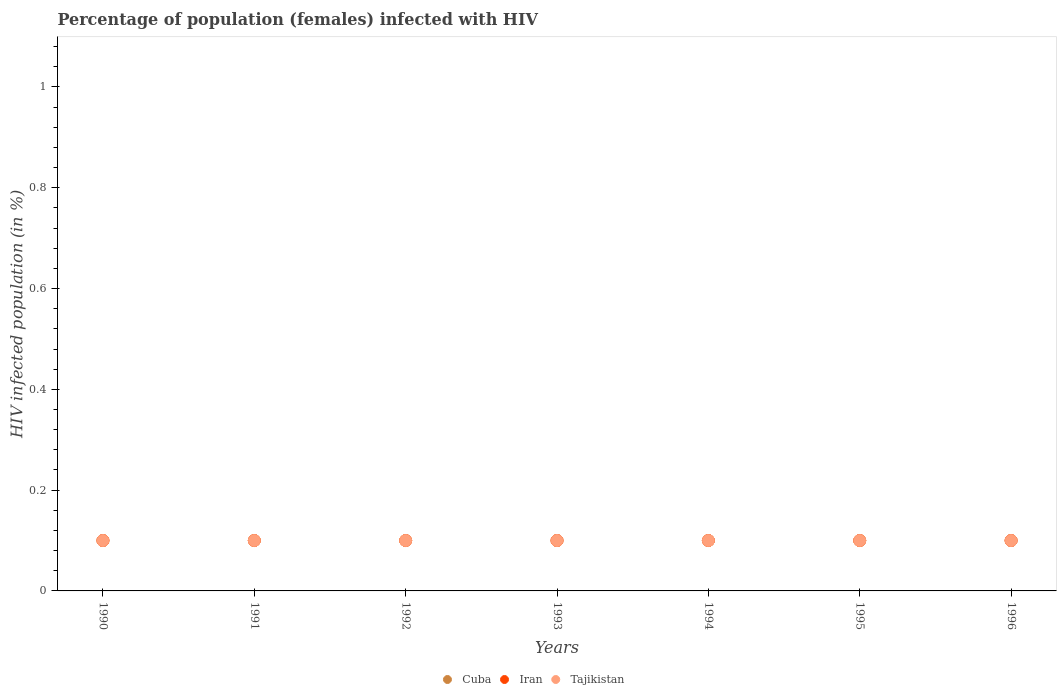How many different coloured dotlines are there?
Your response must be concise. 3. Is the number of dotlines equal to the number of legend labels?
Give a very brief answer. Yes. What is the percentage of HIV infected female population in Cuba in 1996?
Provide a succinct answer. 0.1. In which year was the percentage of HIV infected female population in Tajikistan maximum?
Provide a succinct answer. 1990. In which year was the percentage of HIV infected female population in Iran minimum?
Make the answer very short. 1990. What is the difference between the percentage of HIV infected female population in Tajikistan in 1995 and the percentage of HIV infected female population in Cuba in 1990?
Offer a terse response. 0. What is the average percentage of HIV infected female population in Iran per year?
Offer a very short reply. 0.1. What is the ratio of the percentage of HIV infected female population in Tajikistan in 1995 to that in 1996?
Offer a very short reply. 1. Is the percentage of HIV infected female population in Iran in 1993 less than that in 1995?
Offer a very short reply. No. What is the difference between the highest and the second highest percentage of HIV infected female population in Iran?
Your response must be concise. 0. Is the sum of the percentage of HIV infected female population in Cuba in 1990 and 1993 greater than the maximum percentage of HIV infected female population in Iran across all years?
Your answer should be very brief. Yes. Is it the case that in every year, the sum of the percentage of HIV infected female population in Tajikistan and percentage of HIV infected female population in Iran  is greater than the percentage of HIV infected female population in Cuba?
Offer a very short reply. Yes. Does the percentage of HIV infected female population in Iran monotonically increase over the years?
Ensure brevity in your answer.  No. Is the percentage of HIV infected female population in Tajikistan strictly less than the percentage of HIV infected female population in Iran over the years?
Offer a very short reply. No. How many dotlines are there?
Keep it short and to the point. 3. How many years are there in the graph?
Offer a terse response. 7. Are the values on the major ticks of Y-axis written in scientific E-notation?
Make the answer very short. No. Does the graph contain grids?
Your answer should be compact. No. Where does the legend appear in the graph?
Provide a succinct answer. Bottom center. How many legend labels are there?
Keep it short and to the point. 3. How are the legend labels stacked?
Offer a terse response. Horizontal. What is the title of the graph?
Provide a short and direct response. Percentage of population (females) infected with HIV. Does "North America" appear as one of the legend labels in the graph?
Offer a very short reply. No. What is the label or title of the Y-axis?
Provide a short and direct response. HIV infected population (in %). What is the HIV infected population (in %) of Cuba in 1990?
Give a very brief answer. 0.1. What is the HIV infected population (in %) of Tajikistan in 1990?
Your answer should be compact. 0.1. What is the HIV infected population (in %) in Iran in 1991?
Offer a very short reply. 0.1. What is the HIV infected population (in %) of Tajikistan in 1991?
Your answer should be compact. 0.1. What is the HIV infected population (in %) in Cuba in 1992?
Your answer should be compact. 0.1. What is the HIV infected population (in %) in Iran in 1993?
Provide a short and direct response. 0.1. What is the HIV infected population (in %) in Cuba in 1994?
Offer a very short reply. 0.1. What is the HIV infected population (in %) of Cuba in 1995?
Offer a very short reply. 0.1. What is the HIV infected population (in %) of Tajikistan in 1996?
Offer a terse response. 0.1. Across all years, what is the maximum HIV infected population (in %) in Iran?
Make the answer very short. 0.1. Across all years, what is the minimum HIV infected population (in %) in Cuba?
Your response must be concise. 0.1. Across all years, what is the minimum HIV infected population (in %) of Tajikistan?
Provide a succinct answer. 0.1. What is the total HIV infected population (in %) in Cuba in the graph?
Ensure brevity in your answer.  0.7. What is the difference between the HIV infected population (in %) in Cuba in 1990 and that in 1991?
Make the answer very short. 0. What is the difference between the HIV infected population (in %) in Cuba in 1990 and that in 1992?
Keep it short and to the point. 0. What is the difference between the HIV infected population (in %) in Iran in 1990 and that in 1992?
Give a very brief answer. 0. What is the difference between the HIV infected population (in %) of Iran in 1990 and that in 1993?
Offer a terse response. 0. What is the difference between the HIV infected population (in %) in Tajikistan in 1990 and that in 1994?
Keep it short and to the point. 0. What is the difference between the HIV infected population (in %) of Iran in 1990 and that in 1995?
Provide a succinct answer. 0. What is the difference between the HIV infected population (in %) in Iran in 1990 and that in 1996?
Provide a succinct answer. 0. What is the difference between the HIV infected population (in %) in Iran in 1991 and that in 1992?
Your answer should be very brief. 0. What is the difference between the HIV infected population (in %) in Tajikistan in 1991 and that in 1992?
Your answer should be compact. 0. What is the difference between the HIV infected population (in %) in Tajikistan in 1991 and that in 1993?
Provide a short and direct response. 0. What is the difference between the HIV infected population (in %) of Iran in 1991 and that in 1994?
Offer a very short reply. 0. What is the difference between the HIV infected population (in %) in Tajikistan in 1991 and that in 1995?
Offer a terse response. 0. What is the difference between the HIV infected population (in %) of Cuba in 1991 and that in 1996?
Offer a very short reply. 0. What is the difference between the HIV infected population (in %) of Iran in 1991 and that in 1996?
Keep it short and to the point. 0. What is the difference between the HIV infected population (in %) in Iran in 1992 and that in 1993?
Keep it short and to the point. 0. What is the difference between the HIV infected population (in %) in Tajikistan in 1992 and that in 1993?
Your answer should be very brief. 0. What is the difference between the HIV infected population (in %) in Cuba in 1992 and that in 1996?
Make the answer very short. 0. What is the difference between the HIV infected population (in %) of Tajikistan in 1992 and that in 1996?
Your answer should be compact. 0. What is the difference between the HIV infected population (in %) in Cuba in 1993 and that in 1994?
Offer a terse response. 0. What is the difference between the HIV infected population (in %) in Iran in 1993 and that in 1995?
Offer a terse response. 0. What is the difference between the HIV infected population (in %) in Tajikistan in 1993 and that in 1996?
Your answer should be compact. 0. What is the difference between the HIV infected population (in %) in Cuba in 1994 and that in 1995?
Your answer should be very brief. 0. What is the difference between the HIV infected population (in %) of Iran in 1994 and that in 1995?
Give a very brief answer. 0. What is the difference between the HIV infected population (in %) of Tajikistan in 1994 and that in 1995?
Your answer should be compact. 0. What is the difference between the HIV infected population (in %) of Tajikistan in 1994 and that in 1996?
Provide a short and direct response. 0. What is the difference between the HIV infected population (in %) in Cuba in 1995 and that in 1996?
Offer a very short reply. 0. What is the difference between the HIV infected population (in %) in Iran in 1995 and that in 1996?
Your answer should be very brief. 0. What is the difference between the HIV infected population (in %) in Tajikistan in 1995 and that in 1996?
Make the answer very short. 0. What is the difference between the HIV infected population (in %) in Cuba in 1990 and the HIV infected population (in %) in Iran in 1991?
Keep it short and to the point. 0. What is the difference between the HIV infected population (in %) of Cuba in 1990 and the HIV infected population (in %) of Iran in 1992?
Give a very brief answer. 0. What is the difference between the HIV infected population (in %) of Cuba in 1990 and the HIV infected population (in %) of Tajikistan in 1992?
Provide a short and direct response. 0. What is the difference between the HIV infected population (in %) in Iran in 1990 and the HIV infected population (in %) in Tajikistan in 1993?
Your answer should be compact. 0. What is the difference between the HIV infected population (in %) of Cuba in 1990 and the HIV infected population (in %) of Tajikistan in 1994?
Your answer should be compact. 0. What is the difference between the HIV infected population (in %) in Iran in 1990 and the HIV infected population (in %) in Tajikistan in 1994?
Provide a succinct answer. 0. What is the difference between the HIV infected population (in %) of Cuba in 1990 and the HIV infected population (in %) of Iran in 1995?
Provide a succinct answer. 0. What is the difference between the HIV infected population (in %) in Iran in 1990 and the HIV infected population (in %) in Tajikistan in 1995?
Your answer should be compact. 0. What is the difference between the HIV infected population (in %) in Cuba in 1990 and the HIV infected population (in %) in Tajikistan in 1996?
Your answer should be compact. 0. What is the difference between the HIV infected population (in %) in Cuba in 1991 and the HIV infected population (in %) in Iran in 1992?
Give a very brief answer. 0. What is the difference between the HIV infected population (in %) of Iran in 1991 and the HIV infected population (in %) of Tajikistan in 1992?
Offer a very short reply. 0. What is the difference between the HIV infected population (in %) in Cuba in 1991 and the HIV infected population (in %) in Tajikistan in 1993?
Provide a succinct answer. 0. What is the difference between the HIV infected population (in %) of Cuba in 1991 and the HIV infected population (in %) of Iran in 1994?
Provide a short and direct response. 0. What is the difference between the HIV infected population (in %) in Cuba in 1992 and the HIV infected population (in %) in Tajikistan in 1993?
Give a very brief answer. 0. What is the difference between the HIV infected population (in %) of Iran in 1992 and the HIV infected population (in %) of Tajikistan in 1993?
Provide a short and direct response. 0. What is the difference between the HIV infected population (in %) of Cuba in 1992 and the HIV infected population (in %) of Iran in 1994?
Offer a very short reply. 0. What is the difference between the HIV infected population (in %) of Cuba in 1992 and the HIV infected population (in %) of Tajikistan in 1994?
Offer a very short reply. 0. What is the difference between the HIV infected population (in %) in Cuba in 1992 and the HIV infected population (in %) in Iran in 1995?
Provide a succinct answer. 0. What is the difference between the HIV infected population (in %) in Iran in 1992 and the HIV infected population (in %) in Tajikistan in 1995?
Offer a very short reply. 0. What is the difference between the HIV infected population (in %) of Iran in 1992 and the HIV infected population (in %) of Tajikistan in 1996?
Provide a succinct answer. 0. What is the difference between the HIV infected population (in %) in Iran in 1993 and the HIV infected population (in %) in Tajikistan in 1994?
Keep it short and to the point. 0. What is the difference between the HIV infected population (in %) in Cuba in 1993 and the HIV infected population (in %) in Iran in 1995?
Ensure brevity in your answer.  0. What is the difference between the HIV infected population (in %) in Cuba in 1993 and the HIV infected population (in %) in Tajikistan in 1995?
Offer a terse response. 0. What is the difference between the HIV infected population (in %) of Cuba in 1993 and the HIV infected population (in %) of Tajikistan in 1996?
Provide a short and direct response. 0. What is the difference between the HIV infected population (in %) of Iran in 1993 and the HIV infected population (in %) of Tajikistan in 1996?
Your response must be concise. 0. What is the difference between the HIV infected population (in %) of Cuba in 1994 and the HIV infected population (in %) of Iran in 1995?
Provide a short and direct response. 0. What is the difference between the HIV infected population (in %) of Iran in 1994 and the HIV infected population (in %) of Tajikistan in 1995?
Your response must be concise. 0. What is the difference between the HIV infected population (in %) of Cuba in 1994 and the HIV infected population (in %) of Iran in 1996?
Make the answer very short. 0. What is the difference between the HIV infected population (in %) in Cuba in 1994 and the HIV infected population (in %) in Tajikistan in 1996?
Keep it short and to the point. 0. What is the difference between the HIV infected population (in %) in Cuba in 1995 and the HIV infected population (in %) in Iran in 1996?
Ensure brevity in your answer.  0. What is the average HIV infected population (in %) of Cuba per year?
Give a very brief answer. 0.1. What is the average HIV infected population (in %) in Tajikistan per year?
Offer a terse response. 0.1. In the year 1990, what is the difference between the HIV infected population (in %) in Cuba and HIV infected population (in %) in Iran?
Give a very brief answer. 0. In the year 1990, what is the difference between the HIV infected population (in %) in Cuba and HIV infected population (in %) in Tajikistan?
Your answer should be compact. 0. In the year 1990, what is the difference between the HIV infected population (in %) of Iran and HIV infected population (in %) of Tajikistan?
Keep it short and to the point. 0. In the year 1992, what is the difference between the HIV infected population (in %) in Cuba and HIV infected population (in %) in Iran?
Offer a very short reply. 0. In the year 1992, what is the difference between the HIV infected population (in %) of Cuba and HIV infected population (in %) of Tajikistan?
Your response must be concise. 0. In the year 1992, what is the difference between the HIV infected population (in %) of Iran and HIV infected population (in %) of Tajikistan?
Make the answer very short. 0. In the year 1993, what is the difference between the HIV infected population (in %) in Cuba and HIV infected population (in %) in Tajikistan?
Your answer should be very brief. 0. In the year 1994, what is the difference between the HIV infected population (in %) in Iran and HIV infected population (in %) in Tajikistan?
Your answer should be very brief. 0. In the year 1995, what is the difference between the HIV infected population (in %) of Cuba and HIV infected population (in %) of Iran?
Offer a very short reply. 0. In the year 1995, what is the difference between the HIV infected population (in %) of Cuba and HIV infected population (in %) of Tajikistan?
Provide a succinct answer. 0. In the year 1996, what is the difference between the HIV infected population (in %) of Cuba and HIV infected population (in %) of Tajikistan?
Make the answer very short. 0. In the year 1996, what is the difference between the HIV infected population (in %) in Iran and HIV infected population (in %) in Tajikistan?
Provide a short and direct response. 0. What is the ratio of the HIV infected population (in %) in Cuba in 1990 to that in 1991?
Provide a succinct answer. 1. What is the ratio of the HIV infected population (in %) in Iran in 1990 to that in 1991?
Your answer should be very brief. 1. What is the ratio of the HIV infected population (in %) in Tajikistan in 1990 to that in 1991?
Provide a succinct answer. 1. What is the ratio of the HIV infected population (in %) of Tajikistan in 1990 to that in 1992?
Offer a very short reply. 1. What is the ratio of the HIV infected population (in %) of Cuba in 1990 to that in 1993?
Your answer should be compact. 1. What is the ratio of the HIV infected population (in %) of Iran in 1990 to that in 1993?
Make the answer very short. 1. What is the ratio of the HIV infected population (in %) of Tajikistan in 1990 to that in 1993?
Make the answer very short. 1. What is the ratio of the HIV infected population (in %) of Cuba in 1990 to that in 1994?
Give a very brief answer. 1. What is the ratio of the HIV infected population (in %) of Cuba in 1990 to that in 1995?
Provide a short and direct response. 1. What is the ratio of the HIV infected population (in %) in Tajikistan in 1990 to that in 1995?
Ensure brevity in your answer.  1. What is the ratio of the HIV infected population (in %) in Iran in 1990 to that in 1996?
Your answer should be very brief. 1. What is the ratio of the HIV infected population (in %) of Cuba in 1991 to that in 1992?
Keep it short and to the point. 1. What is the ratio of the HIV infected population (in %) of Cuba in 1991 to that in 1993?
Provide a succinct answer. 1. What is the ratio of the HIV infected population (in %) of Tajikistan in 1991 to that in 1993?
Provide a succinct answer. 1. What is the ratio of the HIV infected population (in %) of Cuba in 1991 to that in 1994?
Give a very brief answer. 1. What is the ratio of the HIV infected population (in %) of Iran in 1991 to that in 1994?
Keep it short and to the point. 1. What is the ratio of the HIV infected population (in %) in Tajikistan in 1991 to that in 1994?
Keep it short and to the point. 1. What is the ratio of the HIV infected population (in %) in Cuba in 1991 to that in 1995?
Provide a succinct answer. 1. What is the ratio of the HIV infected population (in %) in Iran in 1991 to that in 1995?
Offer a very short reply. 1. What is the ratio of the HIV infected population (in %) in Tajikistan in 1991 to that in 1996?
Make the answer very short. 1. What is the ratio of the HIV infected population (in %) of Tajikistan in 1992 to that in 1993?
Provide a short and direct response. 1. What is the ratio of the HIV infected population (in %) in Iran in 1992 to that in 1994?
Ensure brevity in your answer.  1. What is the ratio of the HIV infected population (in %) of Tajikistan in 1992 to that in 1994?
Offer a very short reply. 1. What is the ratio of the HIV infected population (in %) in Cuba in 1993 to that in 1994?
Provide a short and direct response. 1. What is the ratio of the HIV infected population (in %) of Iran in 1993 to that in 1994?
Provide a succinct answer. 1. What is the ratio of the HIV infected population (in %) in Tajikistan in 1993 to that in 1994?
Your answer should be very brief. 1. What is the ratio of the HIV infected population (in %) in Iran in 1993 to that in 1995?
Give a very brief answer. 1. What is the ratio of the HIV infected population (in %) in Cuba in 1993 to that in 1996?
Offer a terse response. 1. What is the ratio of the HIV infected population (in %) of Tajikistan in 1993 to that in 1996?
Give a very brief answer. 1. What is the ratio of the HIV infected population (in %) of Cuba in 1994 to that in 1995?
Provide a short and direct response. 1. What is the ratio of the HIV infected population (in %) in Iran in 1994 to that in 1995?
Offer a terse response. 1. What is the ratio of the HIV infected population (in %) in Cuba in 1994 to that in 1996?
Your answer should be compact. 1. What is the ratio of the HIV infected population (in %) of Iran in 1994 to that in 1996?
Give a very brief answer. 1. What is the ratio of the HIV infected population (in %) in Tajikistan in 1994 to that in 1996?
Provide a succinct answer. 1. What is the ratio of the HIV infected population (in %) in Iran in 1995 to that in 1996?
Offer a terse response. 1. What is the difference between the highest and the second highest HIV infected population (in %) of Cuba?
Provide a short and direct response. 0. What is the difference between the highest and the lowest HIV infected population (in %) of Tajikistan?
Provide a succinct answer. 0. 